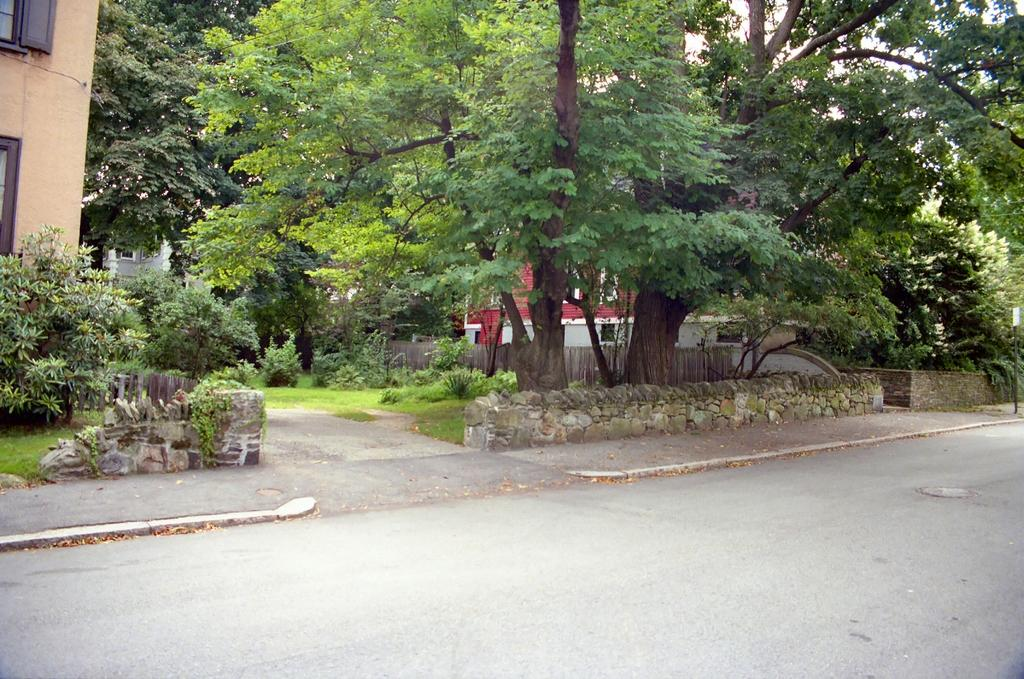What is the main subject of the image? The image depicts a road. What type of vegetation can be seen in the image? Plants, grass, and trees are visible in the image. What type of structure is present in the image? There is a wall and buildings visible in the image. Where is the quicksand located in the image? There is no quicksand present in the image. What color is the nose of the person walking on the road in the image? There is no person or nose visible in the image; it only depicts a road, plants, grass, trees, a wall, and buildings. 